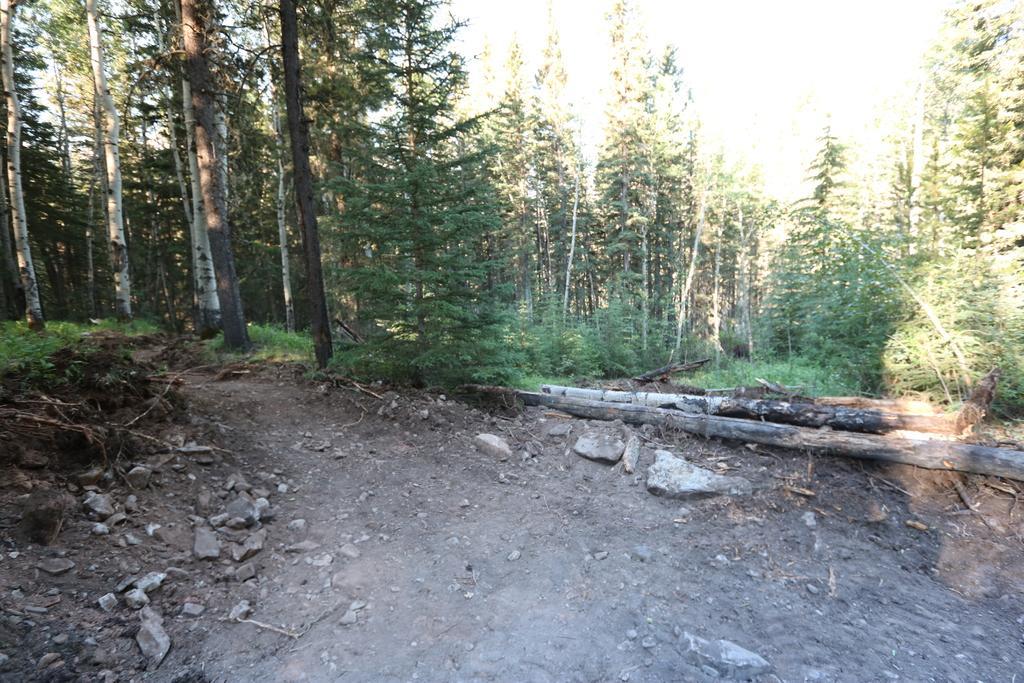Describe this image in one or two sentences. We can see stones, wooden objects, grass and trees. We can see sky. 